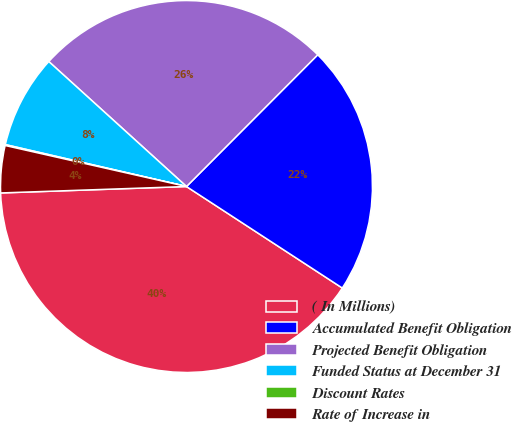Convert chart to OTSL. <chart><loc_0><loc_0><loc_500><loc_500><pie_chart><fcel>( In Millions)<fcel>Accumulated Benefit Obligation<fcel>Projected Benefit Obligation<fcel>Funded Status at December 31<fcel>Discount Rates<fcel>Rate of Increase in<nl><fcel>40.26%<fcel>21.72%<fcel>25.74%<fcel>8.11%<fcel>0.08%<fcel>4.09%<nl></chart> 